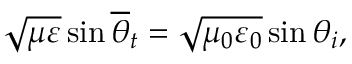<formula> <loc_0><loc_0><loc_500><loc_500>\sqrt { \mu \varepsilon } \sin \overline { \theta } _ { t } = \sqrt { \mu _ { 0 } \varepsilon _ { 0 } } \sin \theta _ { i } ,</formula> 